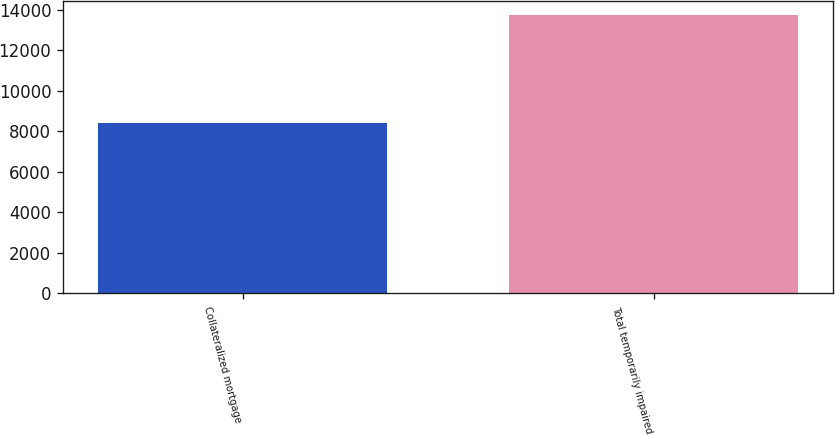Convert chart. <chart><loc_0><loc_0><loc_500><loc_500><bar_chart><fcel>Collateralized mortgage<fcel>Total temporarily impaired<nl><fcel>8396<fcel>13733<nl></chart> 